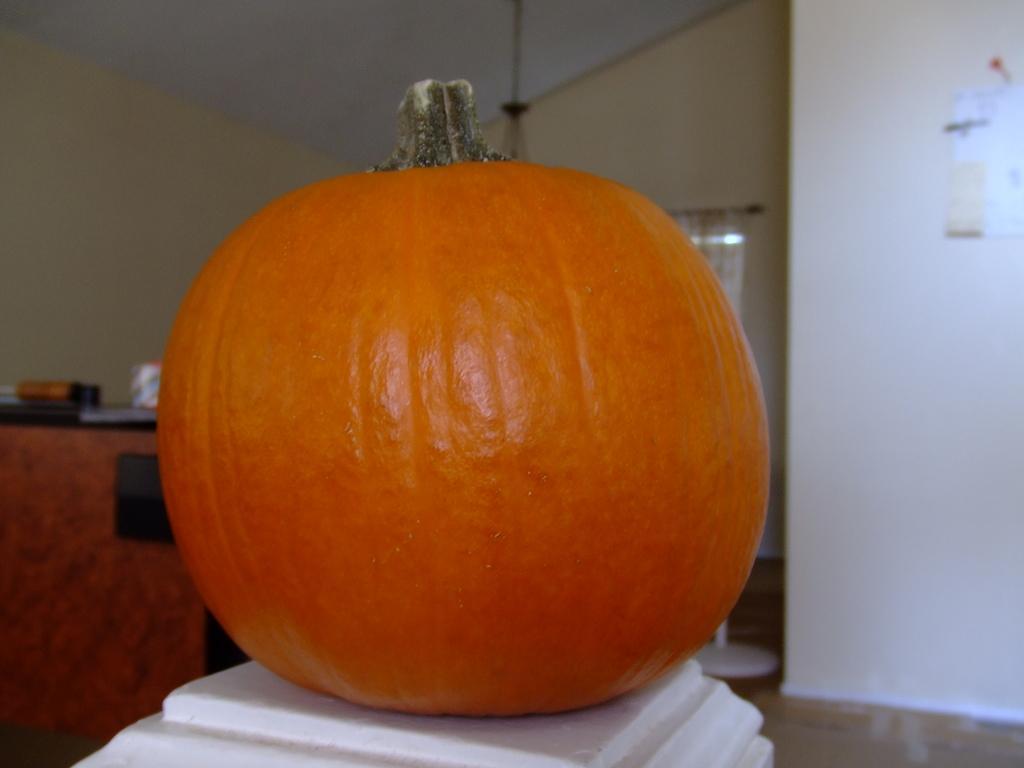In one or two sentences, can you explain what this image depicts? In this image I see a pumpkin which is of orange in color and it is on a white surface. In the background I see the wall and I see the floor and I see a paper over here and I see the ceiling. 